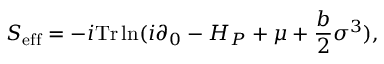<formula> <loc_0><loc_0><loc_500><loc_500>S _ { e f f } = - i T r \ln ( i \partial _ { 0 } - H _ { P } + \mu + \frac { b } { 2 } \sigma ^ { 3 } ) ,</formula> 